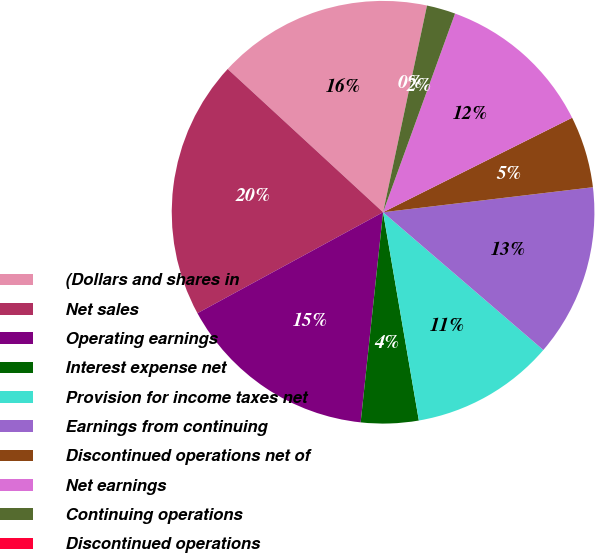<chart> <loc_0><loc_0><loc_500><loc_500><pie_chart><fcel>(Dollars and shares in<fcel>Net sales<fcel>Operating earnings<fcel>Interest expense net<fcel>Provision for income taxes net<fcel>Earnings from continuing<fcel>Discontinued operations net of<fcel>Net earnings<fcel>Continuing operations<fcel>Discontinued operations<nl><fcel>16.48%<fcel>19.78%<fcel>15.38%<fcel>4.4%<fcel>10.99%<fcel>13.19%<fcel>5.49%<fcel>12.09%<fcel>2.2%<fcel>0.0%<nl></chart> 